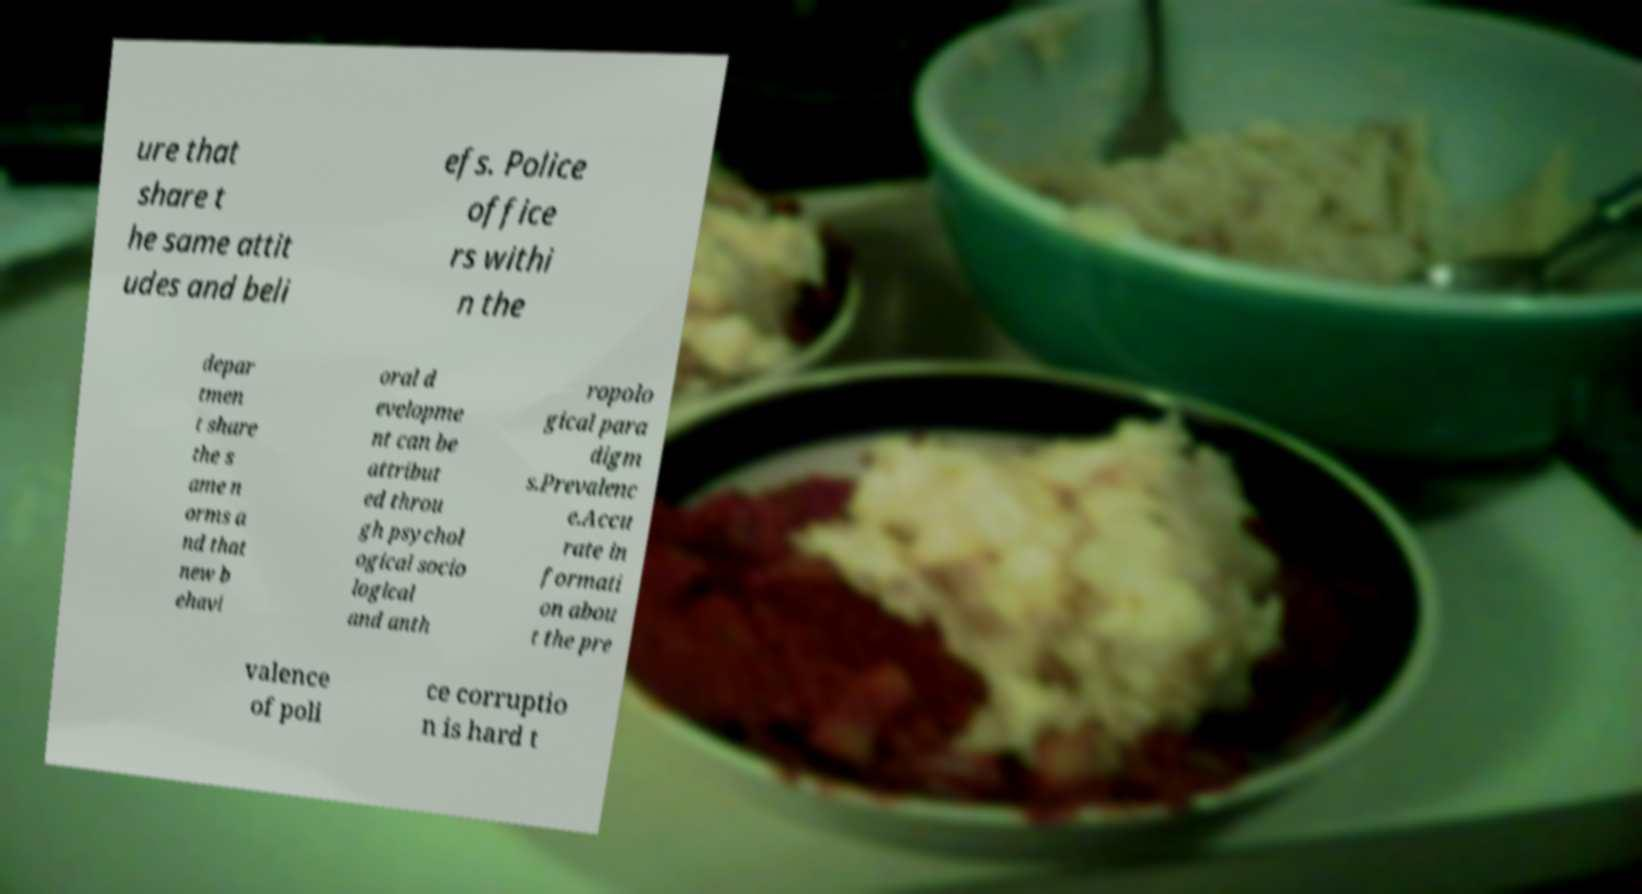There's text embedded in this image that I need extracted. Can you transcribe it verbatim? ure that share t he same attit udes and beli efs. Police office rs withi n the depar tmen t share the s ame n orms a nd that new b ehavi oral d evelopme nt can be attribut ed throu gh psychol ogical socio logical and anth ropolo gical para digm s.Prevalenc e.Accu rate in formati on abou t the pre valence of poli ce corruptio n is hard t 